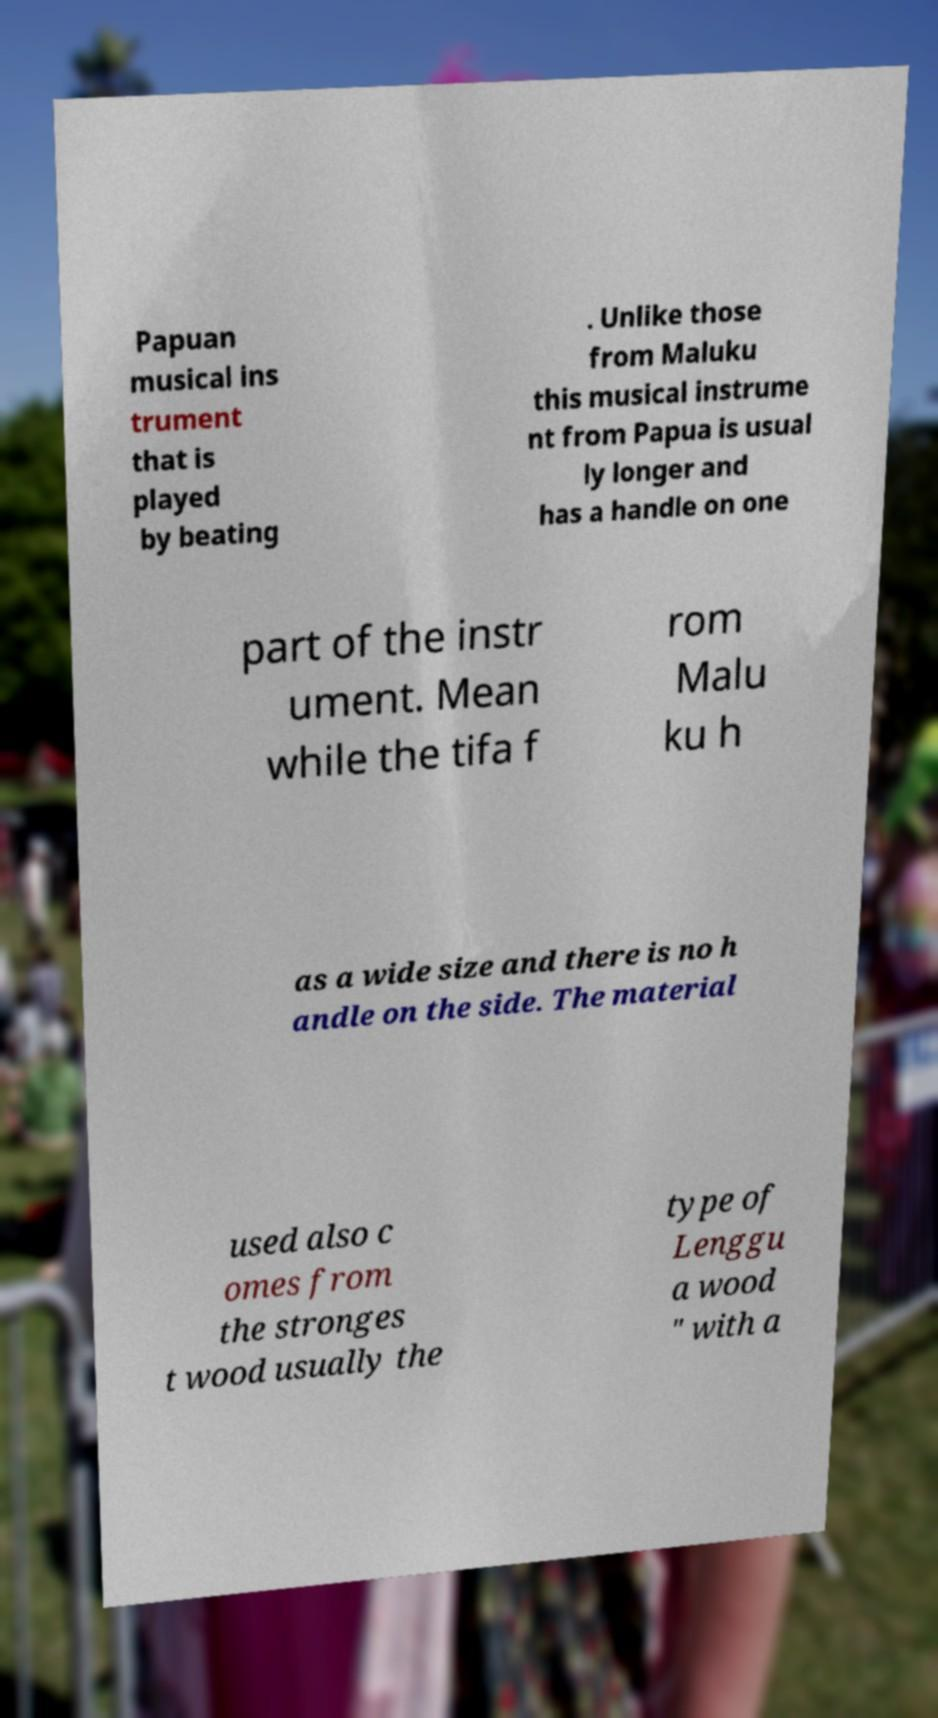I need the written content from this picture converted into text. Can you do that? Papuan musical ins trument that is played by beating . Unlike those from Maluku this musical instrume nt from Papua is usual ly longer and has a handle on one part of the instr ument. Mean while the tifa f rom Malu ku h as a wide size and there is no h andle on the side. The material used also c omes from the stronges t wood usually the type of Lenggu a wood " with a 